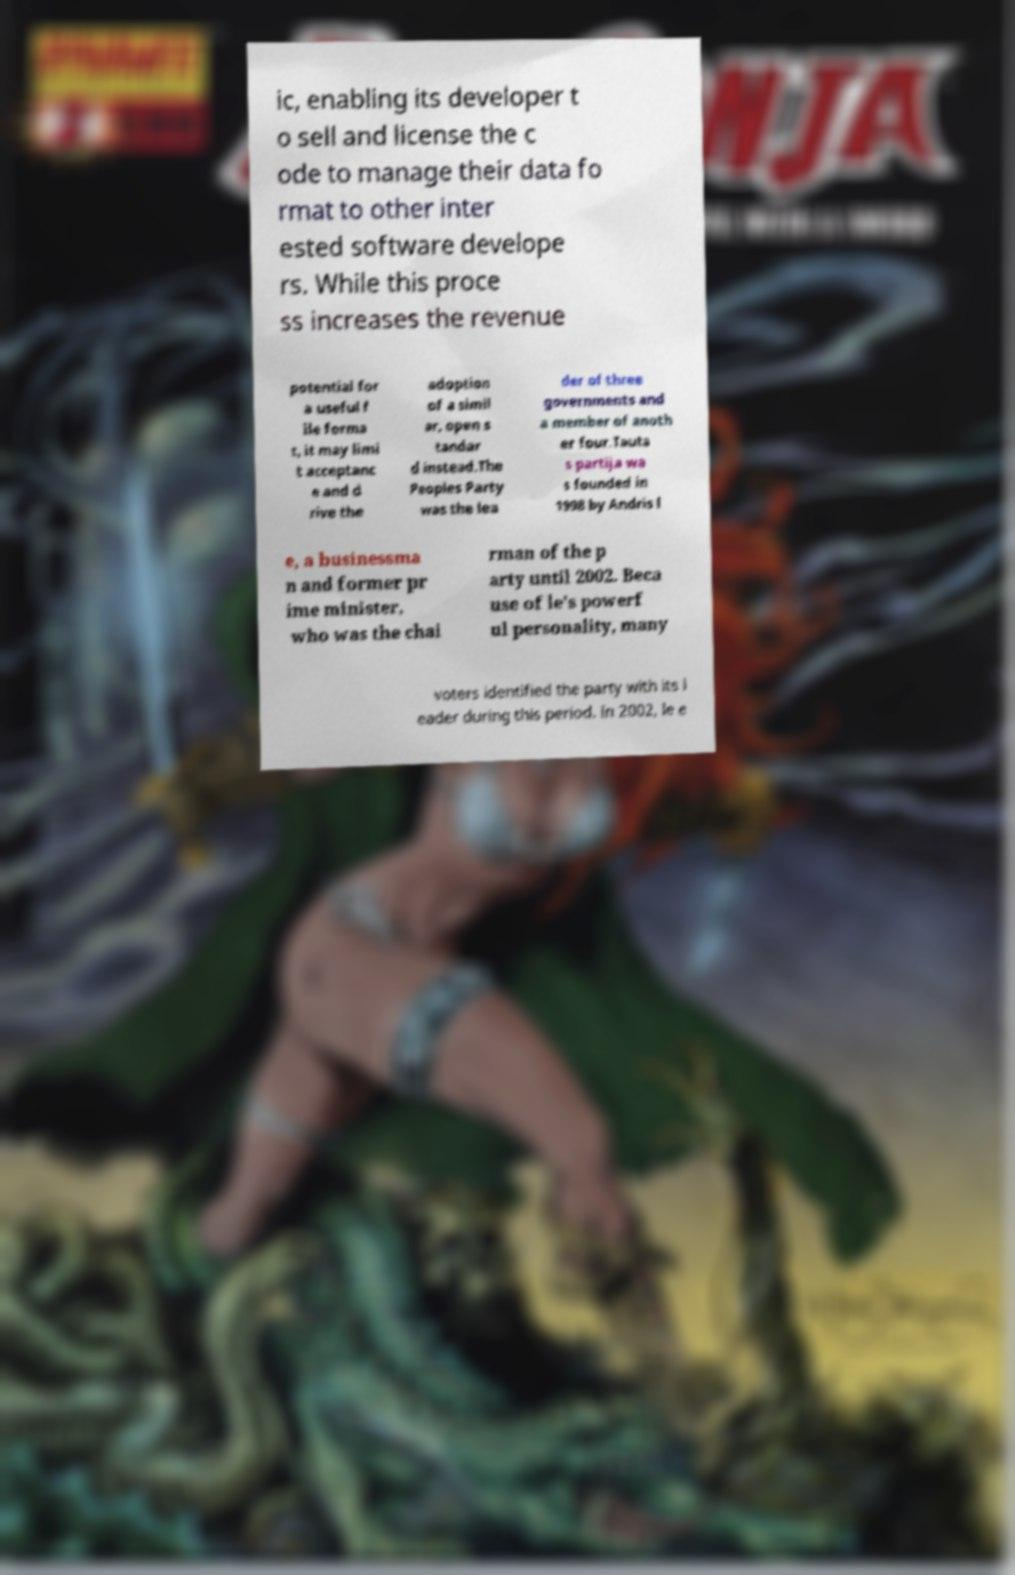I need the written content from this picture converted into text. Can you do that? ic, enabling its developer t o sell and license the c ode to manage their data fo rmat to other inter ested software develope rs. While this proce ss increases the revenue potential for a useful f ile forma t, it may limi t acceptanc e and d rive the adoption of a simil ar, open s tandar d instead.The Peoples Party was the lea der of three governments and a member of anoth er four.Tauta s partija wa s founded in 1998 by Andris l e, a businessma n and former pr ime minister, who was the chai rman of the p arty until 2002. Beca use of le's powerf ul personality, many voters identified the party with its l eader during this period. In 2002, le e 